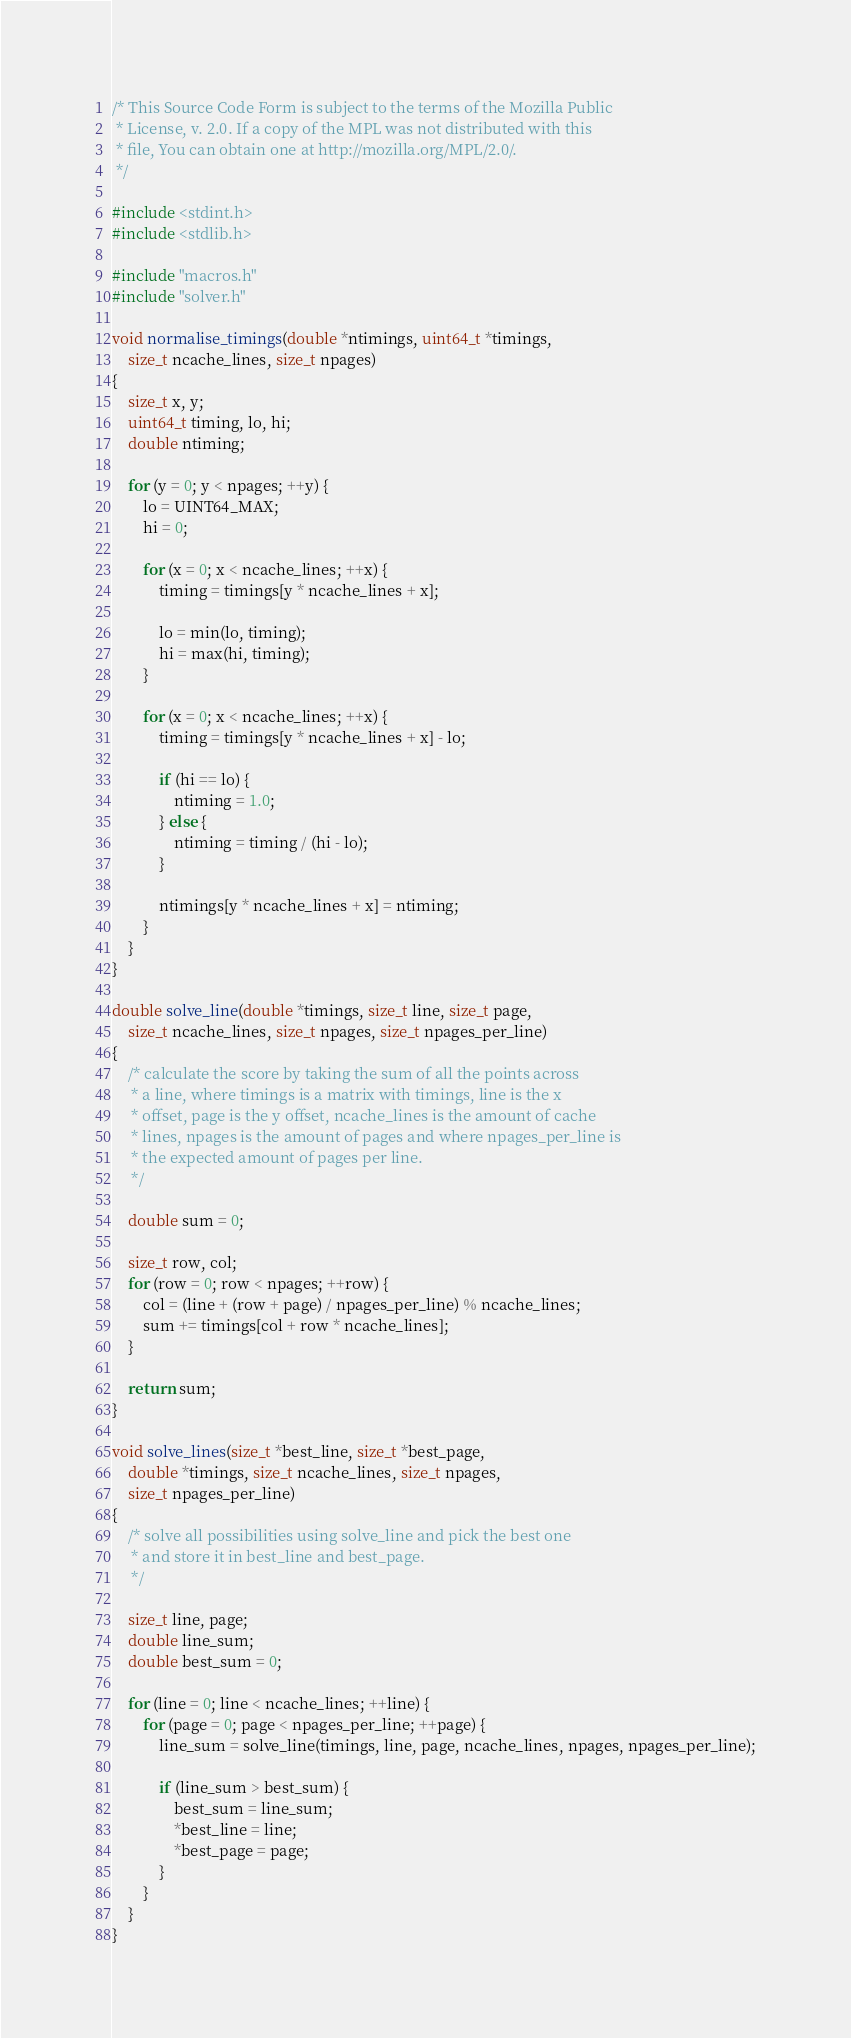<code> <loc_0><loc_0><loc_500><loc_500><_C_>/* This Source Code Form is subject to the terms of the Mozilla Public
 * License, v. 2.0. If a copy of the MPL was not distributed with this
 * file, You can obtain one at http://mozilla.org/MPL/2.0/.
 */

#include <stdint.h>
#include <stdlib.h>

#include "macros.h"
#include "solver.h"

void normalise_timings(double *ntimings, uint64_t *timings,
	size_t ncache_lines, size_t npages)
{
	size_t x, y;
	uint64_t timing, lo, hi;
	double ntiming;

	for (y = 0; y < npages; ++y) {
		lo = UINT64_MAX;
		hi = 0;

		for (x = 0; x < ncache_lines; ++x) {
			timing = timings[y * ncache_lines + x];

			lo = min(lo, timing);
			hi = max(hi, timing);
		}

		for (x = 0; x < ncache_lines; ++x) {
			timing = timings[y * ncache_lines + x] - lo;

			if (hi == lo) {
				ntiming = 1.0;
			} else {
				ntiming = timing / (hi - lo);
			}

			ntimings[y * ncache_lines + x] = ntiming;
		}
	}
}

double solve_line(double *timings, size_t line, size_t page,
	size_t ncache_lines, size_t npages, size_t npages_per_line)
{
	/* calculate the score by taking the sum of all the points across
	 * a line, where timings is a matrix with timings, line is the x
	 * offset, page is the y offset, ncache_lines is the amount of cache
	 * lines, npages is the amount of pages and where npages_per_line is
	 * the expected amount of pages per line.
	 */

	double sum = 0;

	size_t row, col;
	for (row = 0; row < npages; ++row) {
		col = (line + (row + page) / npages_per_line) % ncache_lines;
		sum += timings[col + row * ncache_lines];
	}

	return sum;
}

void solve_lines(size_t *best_line, size_t *best_page,
	double *timings, size_t ncache_lines, size_t npages,
	size_t npages_per_line)
{
	/* solve all possibilities using solve_line and pick the best one
	 * and store it in best_line and best_page.
	 */

	size_t line, page;
	double line_sum;
	double best_sum = 0;

	for (line = 0; line < ncache_lines; ++line) {
		for (page = 0; page < npages_per_line; ++page) {
			line_sum = solve_line(timings, line, page, ncache_lines, npages, npages_per_line);

			if (line_sum > best_sum) {
				best_sum = line_sum;
				*best_line = line;
				*best_page = page;
			}
		}
	}
}
</code> 